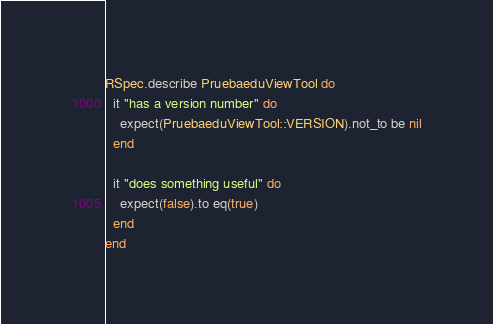Convert code to text. <code><loc_0><loc_0><loc_500><loc_500><_Ruby_>RSpec.describe PruebaeduViewTool do
  it "has a version number" do
    expect(PruebaeduViewTool::VERSION).not_to be nil
  end

  it "does something useful" do
    expect(false).to eq(true)
  end
end
</code> 